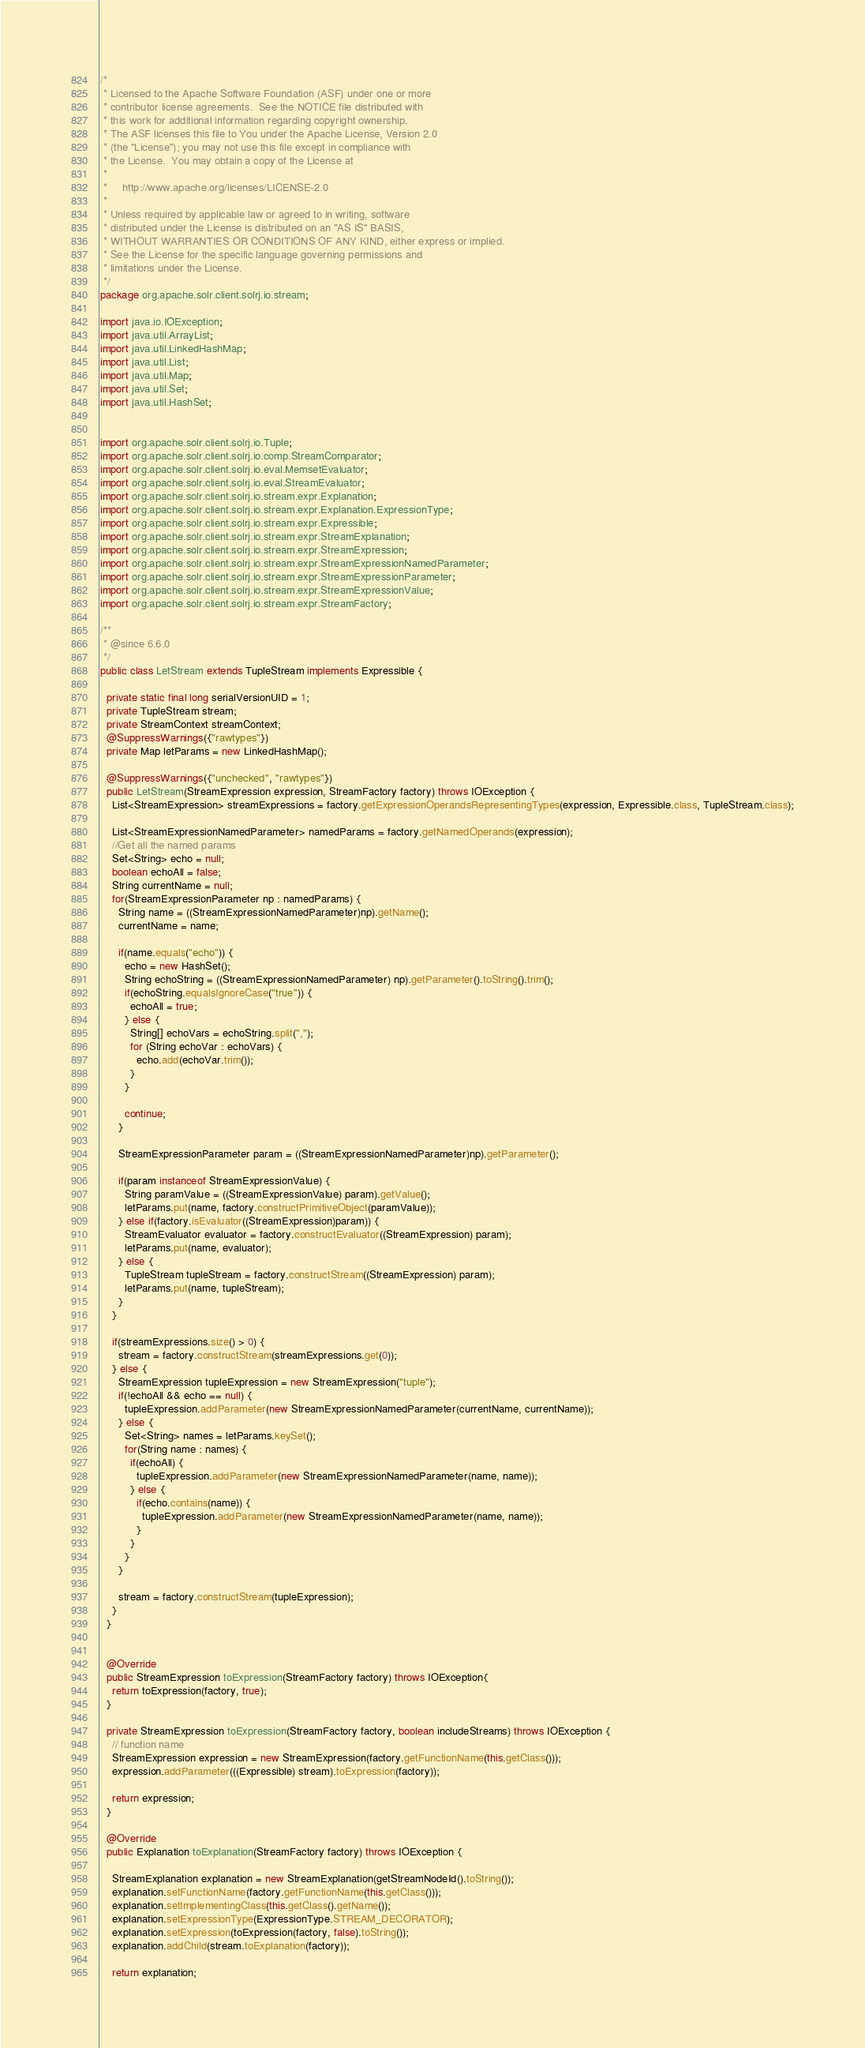Convert code to text. <code><loc_0><loc_0><loc_500><loc_500><_Java_>/*
 * Licensed to the Apache Software Foundation (ASF) under one or more
 * contributor license agreements.  See the NOTICE file distributed with
 * this work for additional information regarding copyright ownership.
 * The ASF licenses this file to You under the Apache License, Version 2.0
 * (the "License"); you may not use this file except in compliance with
 * the License.  You may obtain a copy of the License at
 *
 *     http://www.apache.org/licenses/LICENSE-2.0
 *
 * Unless required by applicable law or agreed to in writing, software
 * distributed under the License is distributed on an "AS IS" BASIS,
 * WITHOUT WARRANTIES OR CONDITIONS OF ANY KIND, either express or implied.
 * See the License for the specific language governing permissions and
 * limitations under the License.
 */
package org.apache.solr.client.solrj.io.stream;

import java.io.IOException;
import java.util.ArrayList;
import java.util.LinkedHashMap;
import java.util.List;
import java.util.Map;
import java.util.Set;
import java.util.HashSet;


import org.apache.solr.client.solrj.io.Tuple;
import org.apache.solr.client.solrj.io.comp.StreamComparator;
import org.apache.solr.client.solrj.io.eval.MemsetEvaluator;
import org.apache.solr.client.solrj.io.eval.StreamEvaluator;
import org.apache.solr.client.solrj.io.stream.expr.Explanation;
import org.apache.solr.client.solrj.io.stream.expr.Explanation.ExpressionType;
import org.apache.solr.client.solrj.io.stream.expr.Expressible;
import org.apache.solr.client.solrj.io.stream.expr.StreamExplanation;
import org.apache.solr.client.solrj.io.stream.expr.StreamExpression;
import org.apache.solr.client.solrj.io.stream.expr.StreamExpressionNamedParameter;
import org.apache.solr.client.solrj.io.stream.expr.StreamExpressionParameter;
import org.apache.solr.client.solrj.io.stream.expr.StreamExpressionValue;
import org.apache.solr.client.solrj.io.stream.expr.StreamFactory;

/**
 * @since 6.6.0
 */
public class LetStream extends TupleStream implements Expressible {

  private static final long serialVersionUID = 1;
  private TupleStream stream;
  private StreamContext streamContext;
  @SuppressWarnings({"rawtypes"})
  private Map letParams = new LinkedHashMap();

  @SuppressWarnings({"unchecked", "rawtypes"})
  public LetStream(StreamExpression expression, StreamFactory factory) throws IOException {
    List<StreamExpression> streamExpressions = factory.getExpressionOperandsRepresentingTypes(expression, Expressible.class, TupleStream.class);

    List<StreamExpressionNamedParameter> namedParams = factory.getNamedOperands(expression);
    //Get all the named params
    Set<String> echo = null;
    boolean echoAll = false;
    String currentName = null;
    for(StreamExpressionParameter np : namedParams) {
      String name = ((StreamExpressionNamedParameter)np).getName();
      currentName = name;

      if(name.equals("echo")) {
        echo = new HashSet();
        String echoString = ((StreamExpressionNamedParameter) np).getParameter().toString().trim();
        if(echoString.equalsIgnoreCase("true")) {
          echoAll = true;
        } else {
          String[] echoVars = echoString.split(",");
          for (String echoVar : echoVars) {
            echo.add(echoVar.trim());
          }
        }

        continue;
      }

      StreamExpressionParameter param = ((StreamExpressionNamedParameter)np).getParameter();

      if(param instanceof StreamExpressionValue) {
        String paramValue = ((StreamExpressionValue) param).getValue();
        letParams.put(name, factory.constructPrimitiveObject(paramValue));
      } else if(factory.isEvaluator((StreamExpression)param)) {
        StreamEvaluator evaluator = factory.constructEvaluator((StreamExpression) param);
        letParams.put(name, evaluator);
      } else {
        TupleStream tupleStream = factory.constructStream((StreamExpression) param);
        letParams.put(name, tupleStream);
      }
    }

    if(streamExpressions.size() > 0) {
      stream = factory.constructStream(streamExpressions.get(0));
    } else {
      StreamExpression tupleExpression = new StreamExpression("tuple");
      if(!echoAll && echo == null) {
        tupleExpression.addParameter(new StreamExpressionNamedParameter(currentName, currentName));
      } else {
        Set<String> names = letParams.keySet();
        for(String name : names) {
          if(echoAll) {
            tupleExpression.addParameter(new StreamExpressionNamedParameter(name, name));
          } else {
            if(echo.contains(name)) {
              tupleExpression.addParameter(new StreamExpressionNamedParameter(name, name));
            }
          }
        }
      }

      stream = factory.constructStream(tupleExpression);
    }
  }


  @Override
  public StreamExpression toExpression(StreamFactory factory) throws IOException{
    return toExpression(factory, true);
  }

  private StreamExpression toExpression(StreamFactory factory, boolean includeStreams) throws IOException {
    // function name
    StreamExpression expression = new StreamExpression(factory.getFunctionName(this.getClass()));
    expression.addParameter(((Expressible) stream).toExpression(factory));

    return expression;
  }

  @Override
  public Explanation toExplanation(StreamFactory factory) throws IOException {

    StreamExplanation explanation = new StreamExplanation(getStreamNodeId().toString());
    explanation.setFunctionName(factory.getFunctionName(this.getClass()));
    explanation.setImplementingClass(this.getClass().getName());
    explanation.setExpressionType(ExpressionType.STREAM_DECORATOR);
    explanation.setExpression(toExpression(factory, false).toString());
    explanation.addChild(stream.toExplanation(factory));

    return explanation;</code> 